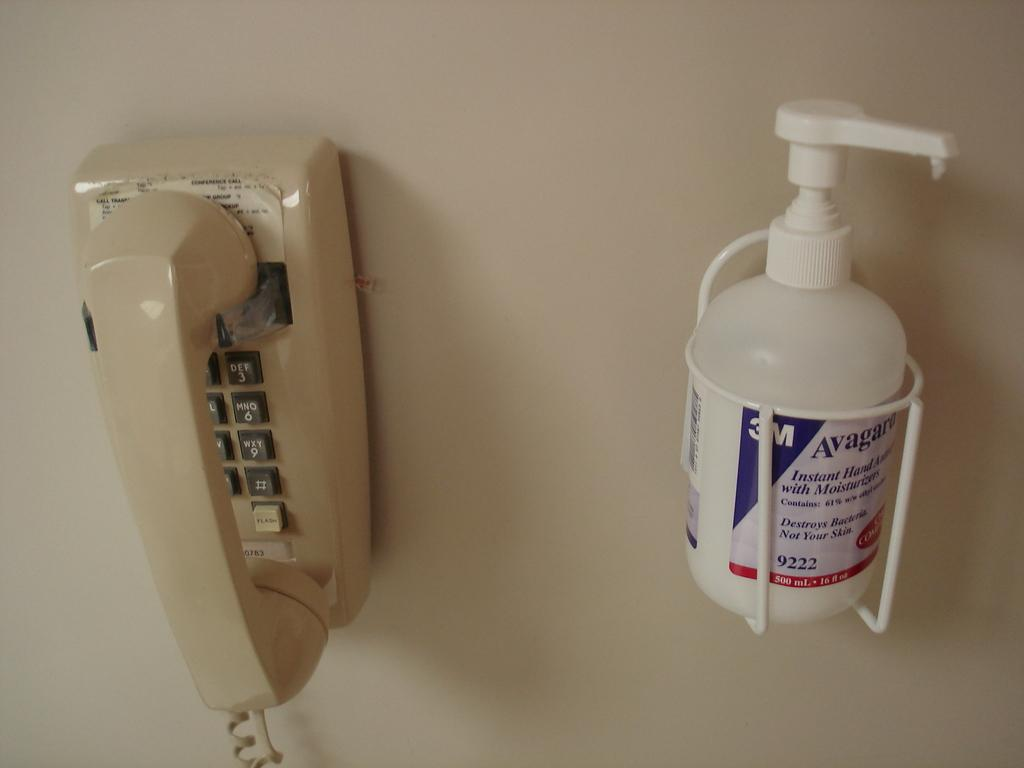What object is attached to the wall in the image? There is a telephone attached to the wall in the image. What else is attached to the wall in the image? The bottle holder is attached to the wall in the image. What is connected to the bottle holder? The bottle is connected to the bottle holder in the image. Can you see any toes in the image? There are no toes visible in the image. What type of coast is shown in the image? There is no coast present in the image. 